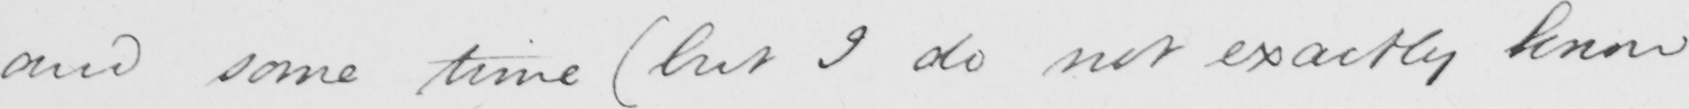Can you read and transcribe this handwriting? and some time  ( but I do not exactly know 